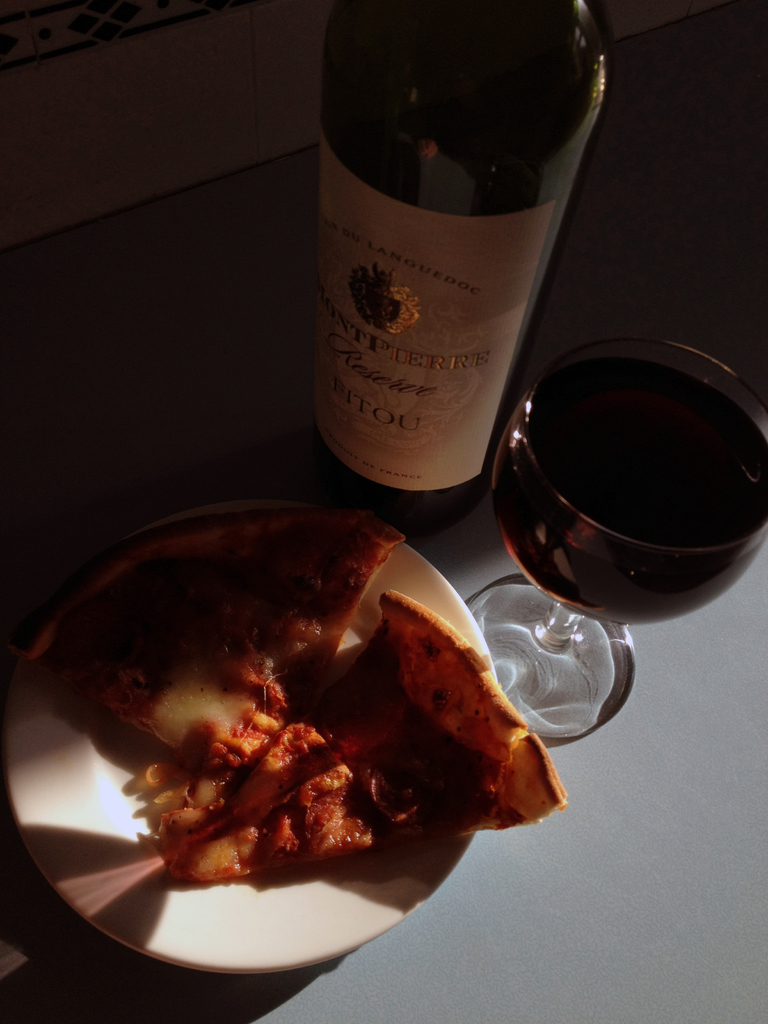Can you tell me more about the type of wine and its typical pairing options? The wine shown is a Montpierre Reserve, a robust red wine from the Languedoc region, typically enjoyed with rich meats, pasta, or a hearty pizza as seen here, emphasizing its versatility and rich flavor profile. 